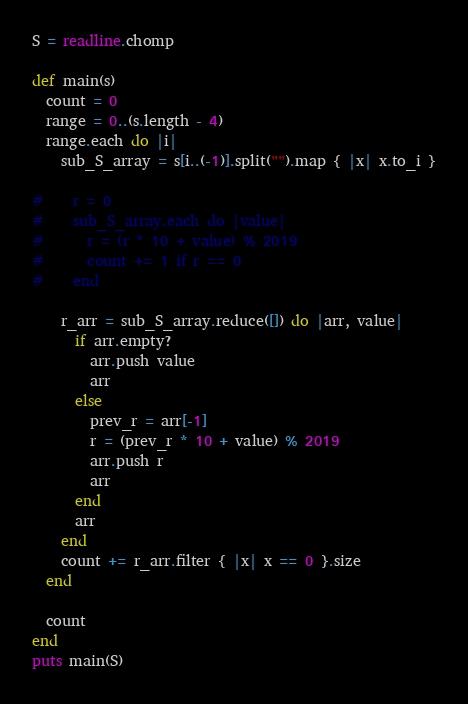Convert code to text. <code><loc_0><loc_0><loc_500><loc_500><_Ruby_>S = readline.chomp

def main(s)
  count = 0
  range = 0..(s.length - 4)
  range.each do |i|
    sub_S_array = s[i..(-1)].split("").map { |x| x.to_i }

#    r = 0
#    sub_S_array.each do |value|
#      r = (r * 10 + value) % 2019
#      count += 1 if r == 0
#    end

    r_arr = sub_S_array.reduce([]) do |arr, value|
      if arr.empty?
        arr.push value
        arr
      else
        prev_r = arr[-1]
        r = (prev_r * 10 + value) % 2019
        arr.push r
        arr
      end
      arr
    end
    count += r_arr.filter { |x| x == 0 }.size
  end

  count
end
puts main(S)</code> 